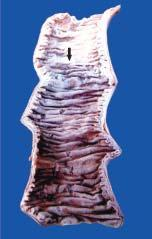s the inner circle shown with green line swollen, dark in colour and coated with fibrinous exudate?
Answer the question using a single word or phrase. No 